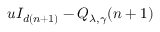Convert formula to latex. <formula><loc_0><loc_0><loc_500><loc_500>u I _ { d ( n + 1 ) } - Q _ { \lambda , \gamma } ( n + 1 )</formula> 